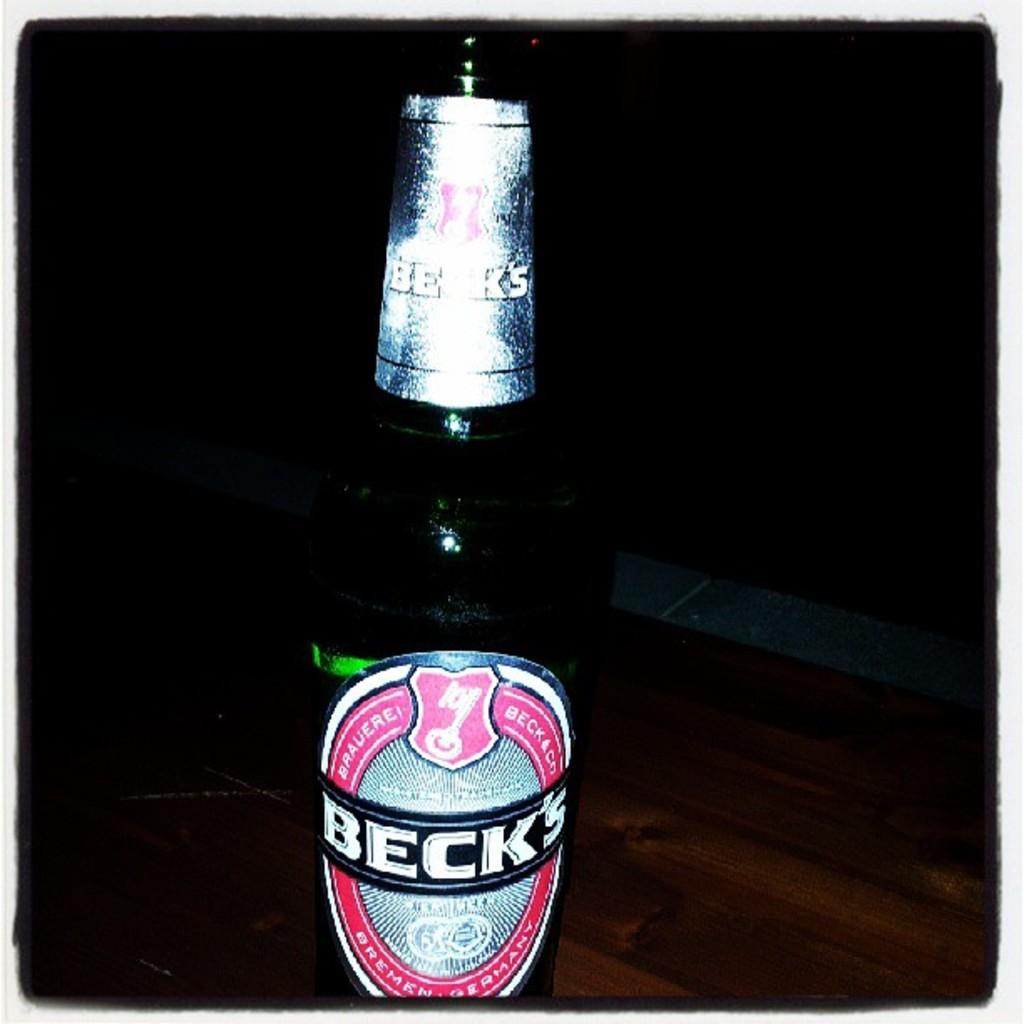<image>
Offer a succinct explanation of the picture presented. a dark bottle of Beck's beer on a wooden table 